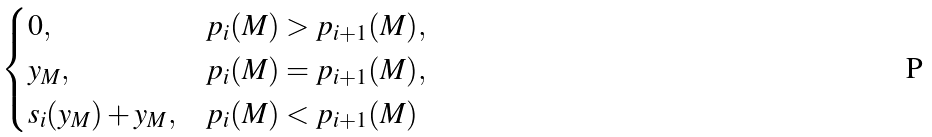<formula> <loc_0><loc_0><loc_500><loc_500>\begin{cases} 0 , & p _ { i } ( M ) > p _ { i + 1 } ( M ) , \\ y _ { M } , & p _ { i } ( M ) = p _ { i + 1 } ( M ) , \\ s _ { i } ( y _ { M } ) + y _ { M } , & p _ { i } ( M ) < p _ { i + 1 } ( M ) \end{cases}</formula> 